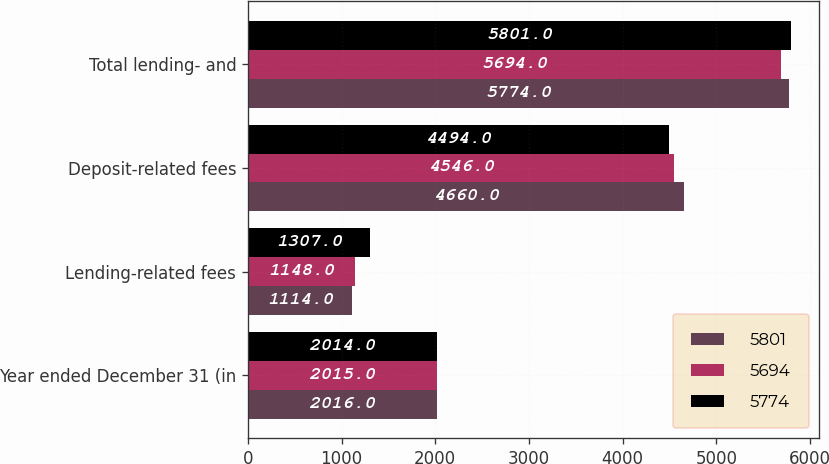Convert chart to OTSL. <chart><loc_0><loc_0><loc_500><loc_500><stacked_bar_chart><ecel><fcel>Year ended December 31 (in<fcel>Lending-related fees<fcel>Deposit-related fees<fcel>Total lending- and<nl><fcel>5801<fcel>2016<fcel>1114<fcel>4660<fcel>5774<nl><fcel>5694<fcel>2015<fcel>1148<fcel>4546<fcel>5694<nl><fcel>5774<fcel>2014<fcel>1307<fcel>4494<fcel>5801<nl></chart> 